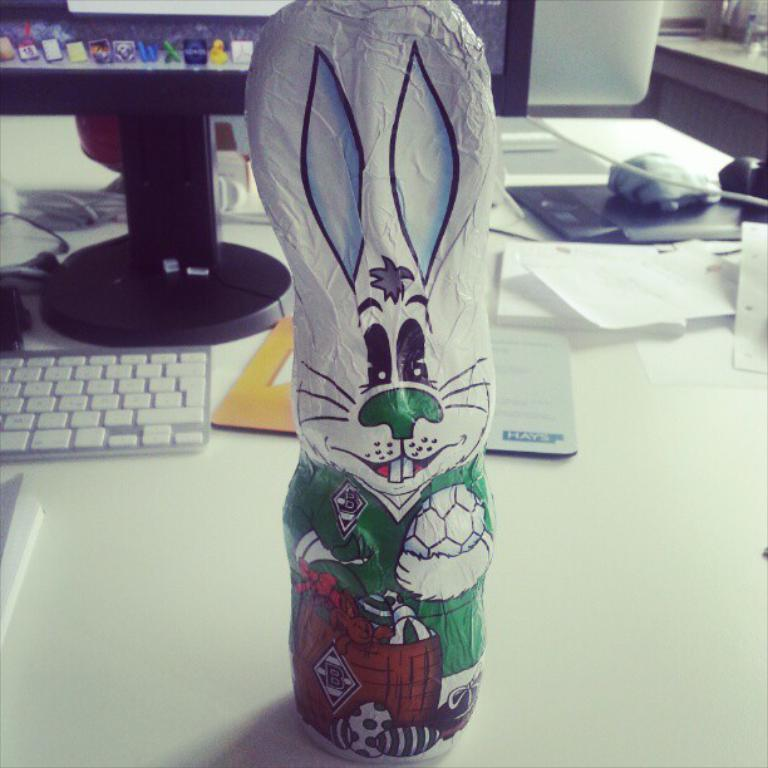What object is placed on the table in the image? There is a toy on a table in the image. What electronic device is visible in the image? There is a keyboard and a monitor in the image. What type of berry is being used as a decoration on the keyboard in the image? There are no berries present in the image, and the keyboard is not being used as a decoration. 